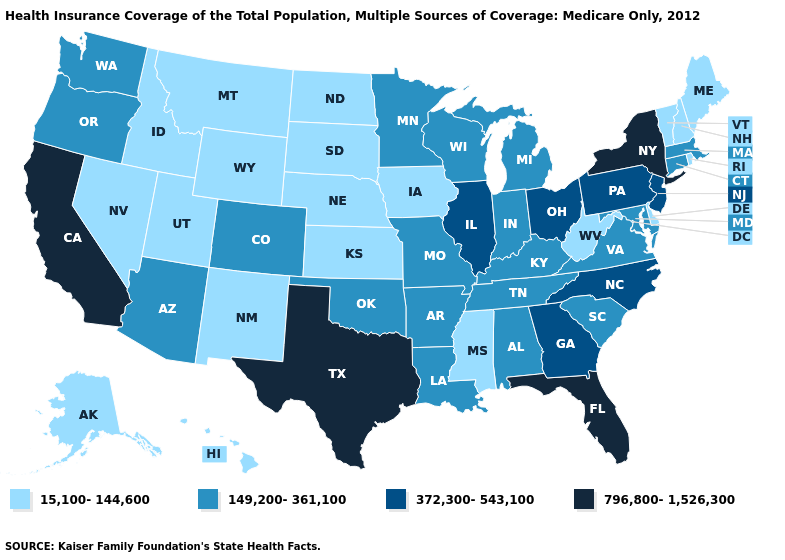Among the states that border Connecticut , which have the highest value?
Write a very short answer. New York. Among the states that border Missouri , which have the lowest value?
Answer briefly. Iowa, Kansas, Nebraska. Name the states that have a value in the range 372,300-543,100?
Keep it brief. Georgia, Illinois, New Jersey, North Carolina, Ohio, Pennsylvania. What is the value of Iowa?
Keep it brief. 15,100-144,600. What is the highest value in the USA?
Write a very short answer. 796,800-1,526,300. Name the states that have a value in the range 149,200-361,100?
Keep it brief. Alabama, Arizona, Arkansas, Colorado, Connecticut, Indiana, Kentucky, Louisiana, Maryland, Massachusetts, Michigan, Minnesota, Missouri, Oklahoma, Oregon, South Carolina, Tennessee, Virginia, Washington, Wisconsin. Does Iowa have a lower value than Louisiana?
Answer briefly. Yes. What is the lowest value in the MidWest?
Keep it brief. 15,100-144,600. Among the states that border Mississippi , which have the lowest value?
Write a very short answer. Alabama, Arkansas, Louisiana, Tennessee. Does the map have missing data?
Short answer required. No. How many symbols are there in the legend?
Be succinct. 4. What is the value of Montana?
Give a very brief answer. 15,100-144,600. Name the states that have a value in the range 372,300-543,100?
Quick response, please. Georgia, Illinois, New Jersey, North Carolina, Ohio, Pennsylvania. What is the value of Maine?
Concise answer only. 15,100-144,600. 